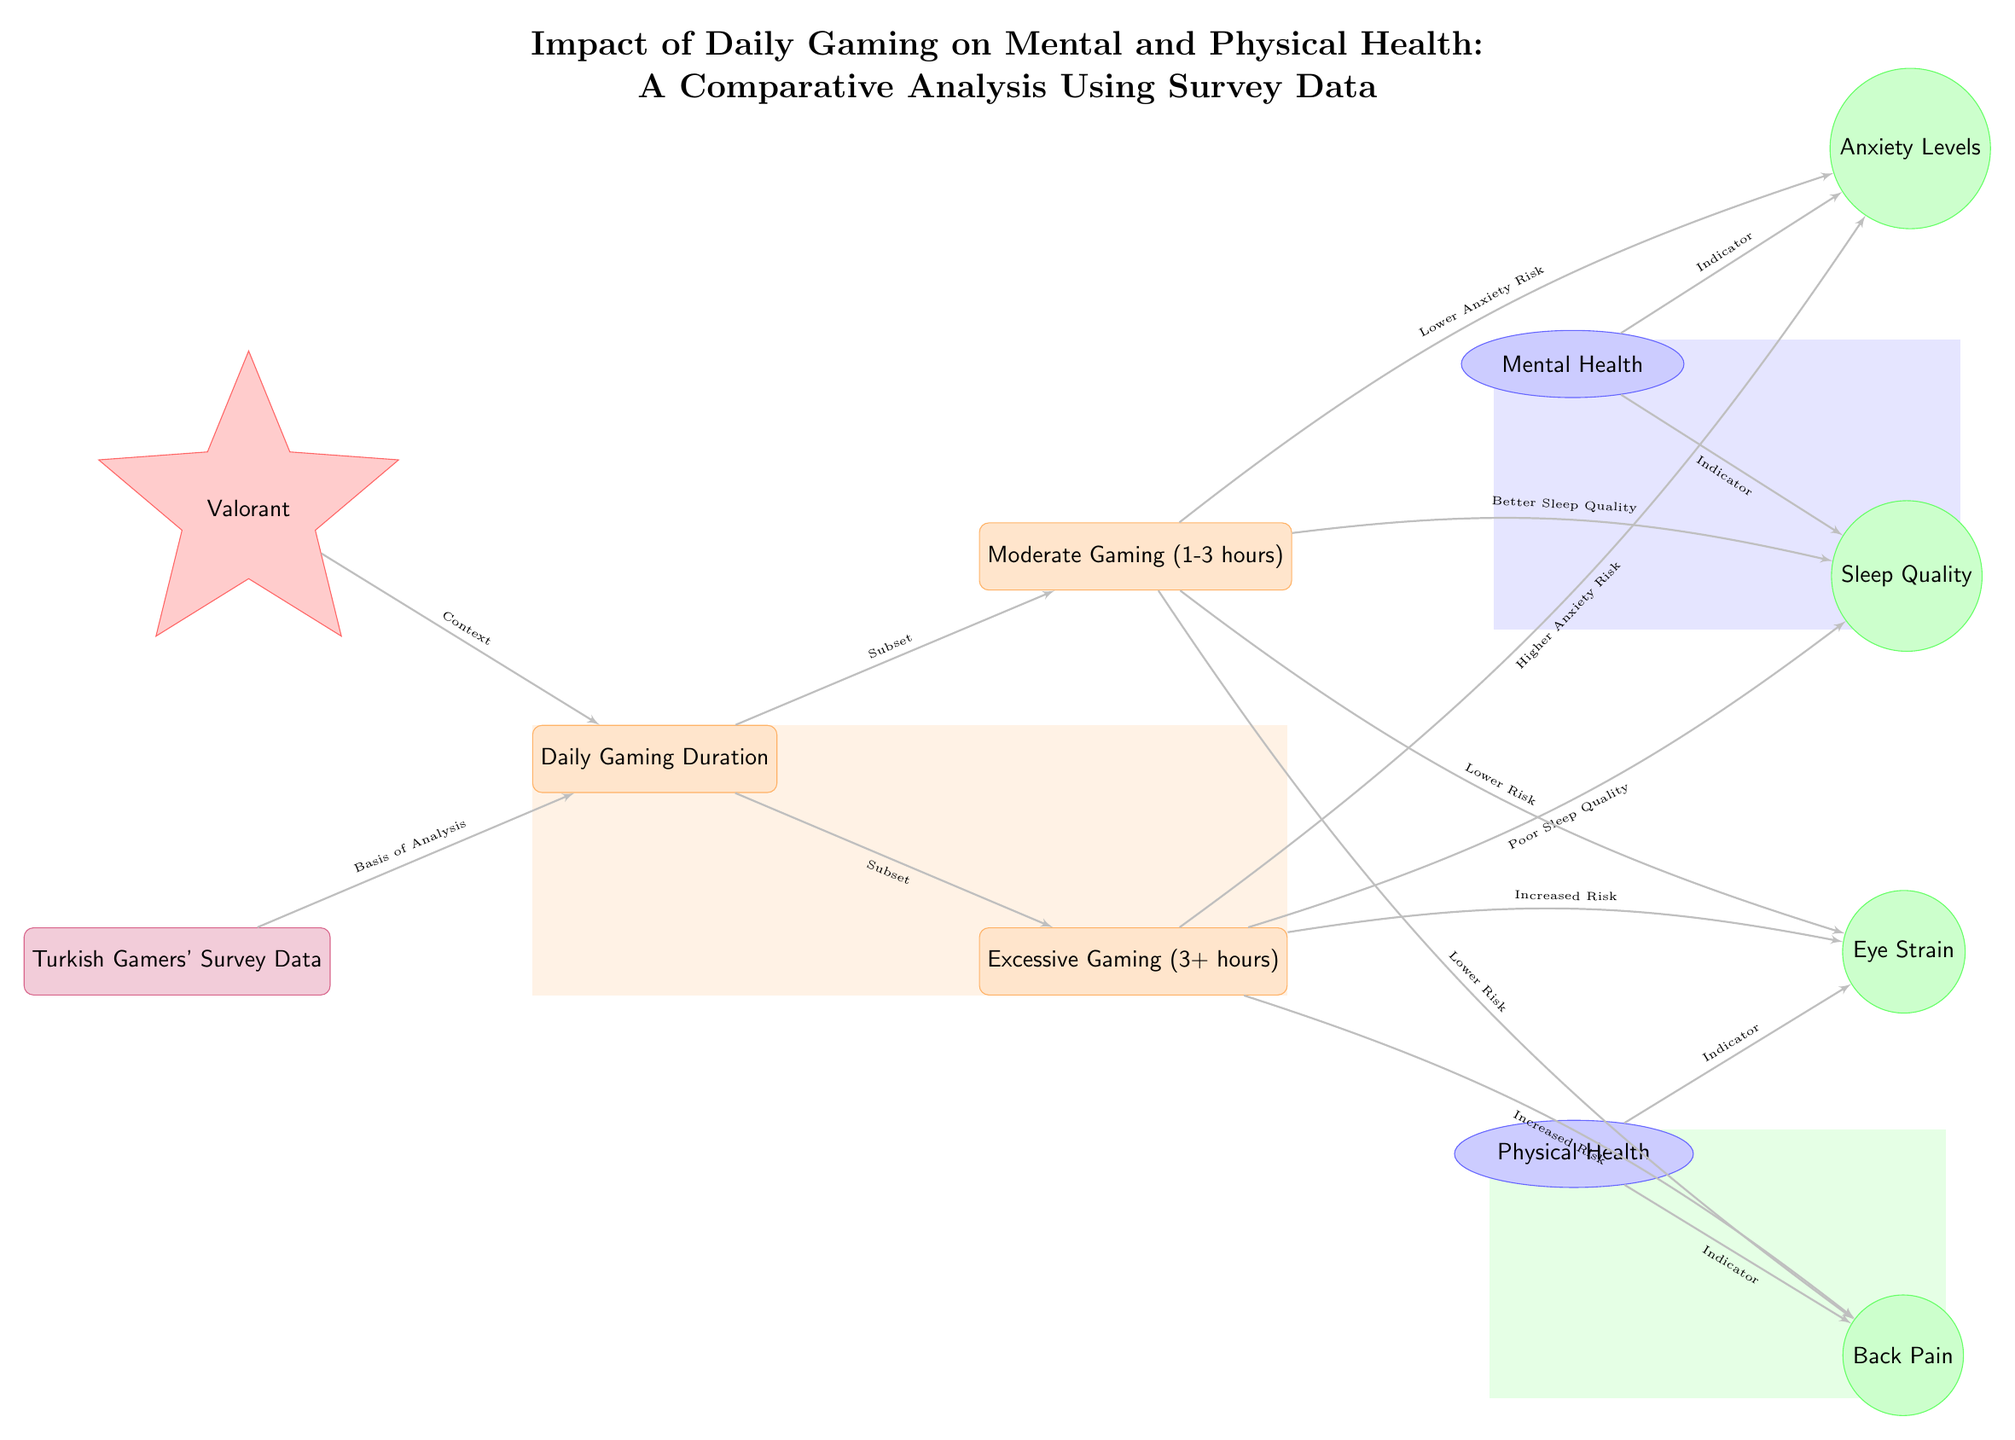What is the basis of analysis in this diagram? The basis of analysis is represented by the node labelled 'Turkish Gamers' Survey Data', which is the initial point of the flow.
Answer: Turkish Gamers' Survey Data How many daily gaming categories are indicated in the diagram? The diagram displays two categories of daily gaming: 'Moderate Gaming (1-3 hours)' and 'Excessive Gaming (3+ hours)'.
Answer: 2 Which gaming context is specifically mentioned in the diagram? The only gaming context specified in the diagram is 'Valorant', which is connected to the daily gaming duration node.
Answer: Valorant What effect is associated with high daily gaming duration regarding mental health? The diagram indicates that 'Excessive Gaming (3+ hours)' is linked to 'Higher Anxiety Risk', which directly connects to anxiety levels.
Answer: Higher Anxiety Risk What type of health does 'Eye Strain' fall under in the diagram? 'Eye Strain' is identified as an effect associated with 'Physical Health' in the diagram.
Answer: Physical Health What should we infer about the relationship between 'Moderate Gaming' and 'Sleep Quality'? The diagram indicates that 'Moderate Gaming (1-3 hours)' leads to 'Better Sleep Quality', showing a positive effect on sleep.
Answer: Better Sleep Quality What are the two indicators listed under Mental Health? The two indicators are 'Anxiety Levels' and 'Sleep Quality', as shown under the mental health category.
Answer: Anxiety Levels, Sleep Quality Which gaming duration is linked to 'Lower Risk' of physical health issues? The node 'Moderate Gaming (1-3 hours)' has been linked to 'Lower Risk' for both 'Eye Strain' and 'Back Pain'.
Answer: Lower Risk How does excessive gaming relate to physical health outcomes? The diagram illustrates that 'Excessive Gaming (3+ hours)' is associated with 'Increased Risk' of both 'Eye Strain' and 'Back Pain'.
Answer: Increased Risk 